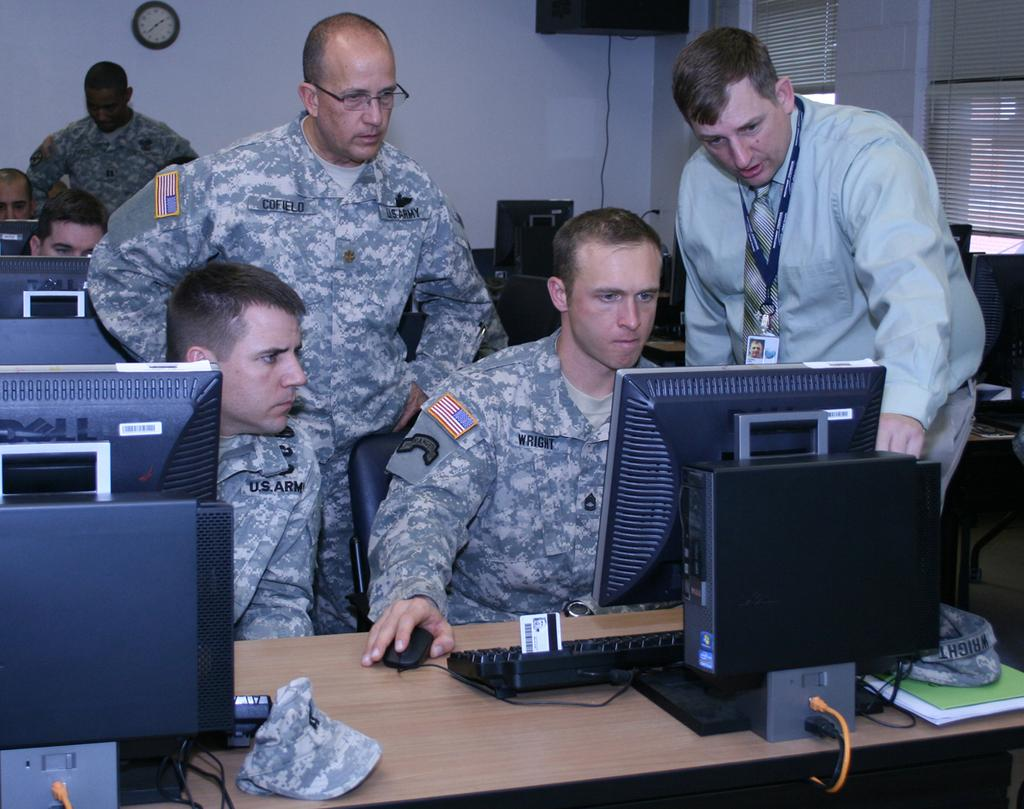<image>
Summarize the visual content of the image. U.s. Army soldiers using a computer with the soldier Wright being taught. 